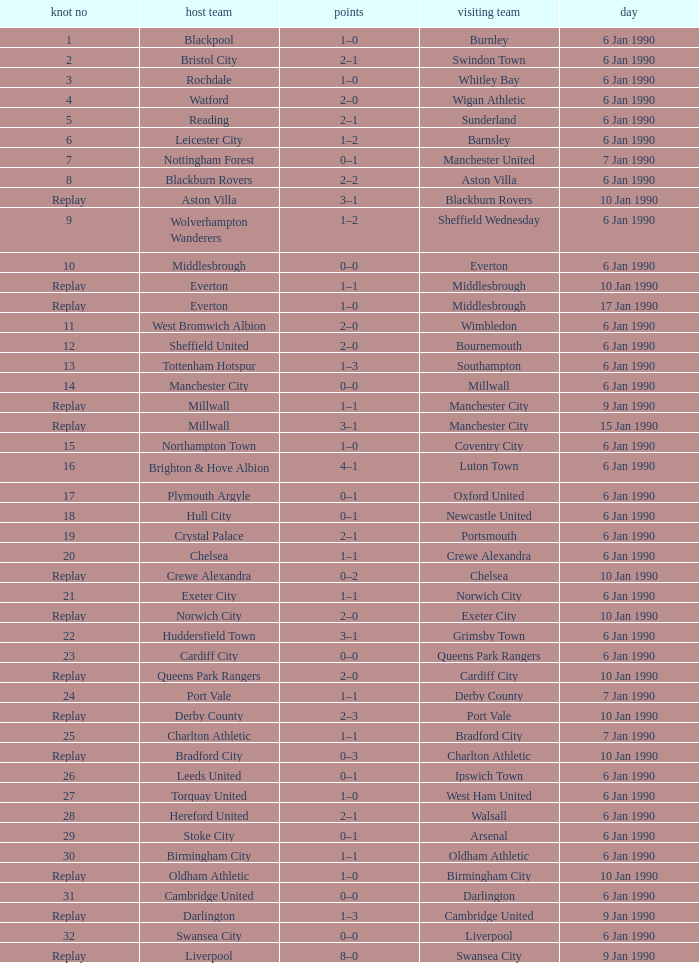What is the score of the game against away team exeter city on 10 jan 1990? 2–0. 